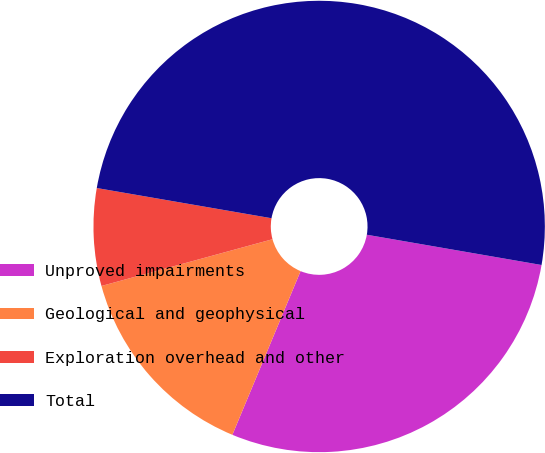Convert chart to OTSL. <chart><loc_0><loc_0><loc_500><loc_500><pie_chart><fcel>Unproved impairments<fcel>Geological and geophysical<fcel>Exploration overhead and other<fcel>Total<nl><fcel>28.55%<fcel>14.47%<fcel>6.97%<fcel>50.0%<nl></chart> 